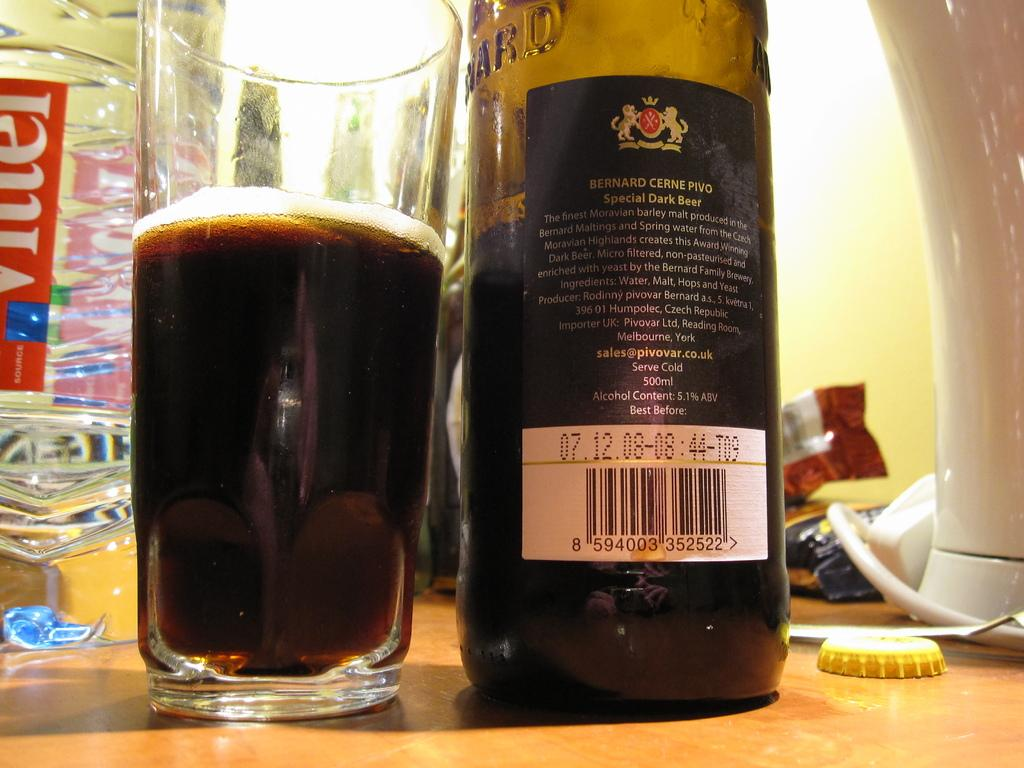<image>
Render a clear and concise summary of the photo. A bottle of Bernard Cerne Pivo dark beer and a glass. 